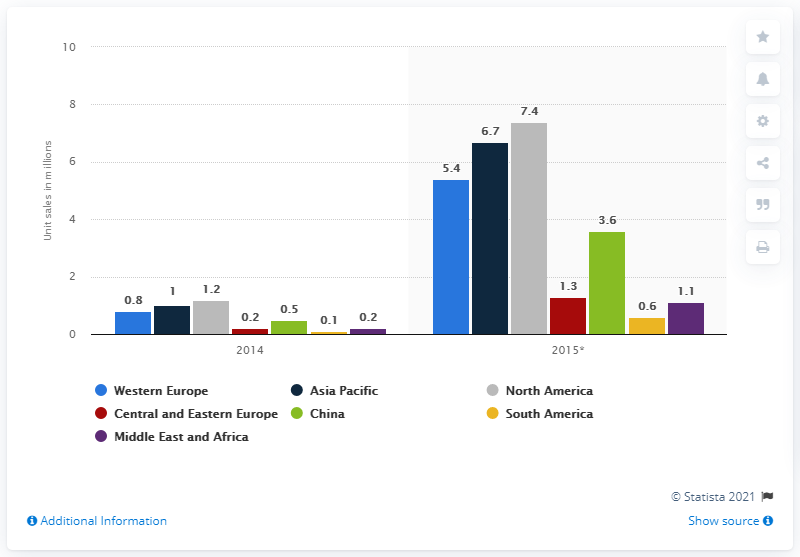Give some essential details in this illustration. According to projections, it is estimated that 7.4 units of smartwatches will be sold in North America in 2015. 